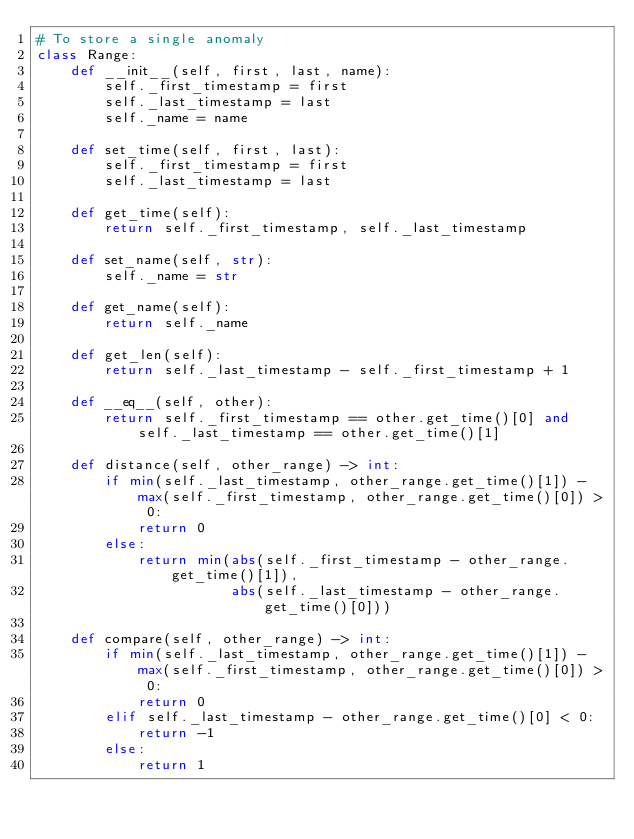Convert code to text. <code><loc_0><loc_0><loc_500><loc_500><_Python_># To store a single anomaly
class Range:
    def __init__(self, first, last, name):
        self._first_timestamp = first
        self._last_timestamp = last
        self._name = name

    def set_time(self, first, last):
        self._first_timestamp = first
        self._last_timestamp = last

    def get_time(self):
        return self._first_timestamp, self._last_timestamp

    def set_name(self, str):
        self._name = str

    def get_name(self):
        return self._name

    def get_len(self):
        return self._last_timestamp - self._first_timestamp + 1

    def __eq__(self, other):
        return self._first_timestamp == other.get_time()[0] and self._last_timestamp == other.get_time()[1]

    def distance(self, other_range) -> int:
        if min(self._last_timestamp, other_range.get_time()[1]) - max(self._first_timestamp, other_range.get_time()[0]) > 0:
            return 0
        else:
            return min(abs(self._first_timestamp - other_range.get_time()[1]),
                       abs(self._last_timestamp - other_range.get_time()[0]))

    def compare(self, other_range) -> int:
        if min(self._last_timestamp, other_range.get_time()[1]) - max(self._first_timestamp, other_range.get_time()[0]) > 0:
            return 0
        elif self._last_timestamp - other_range.get_time()[0] < 0:
            return -1
        else:
            return 1
</code> 